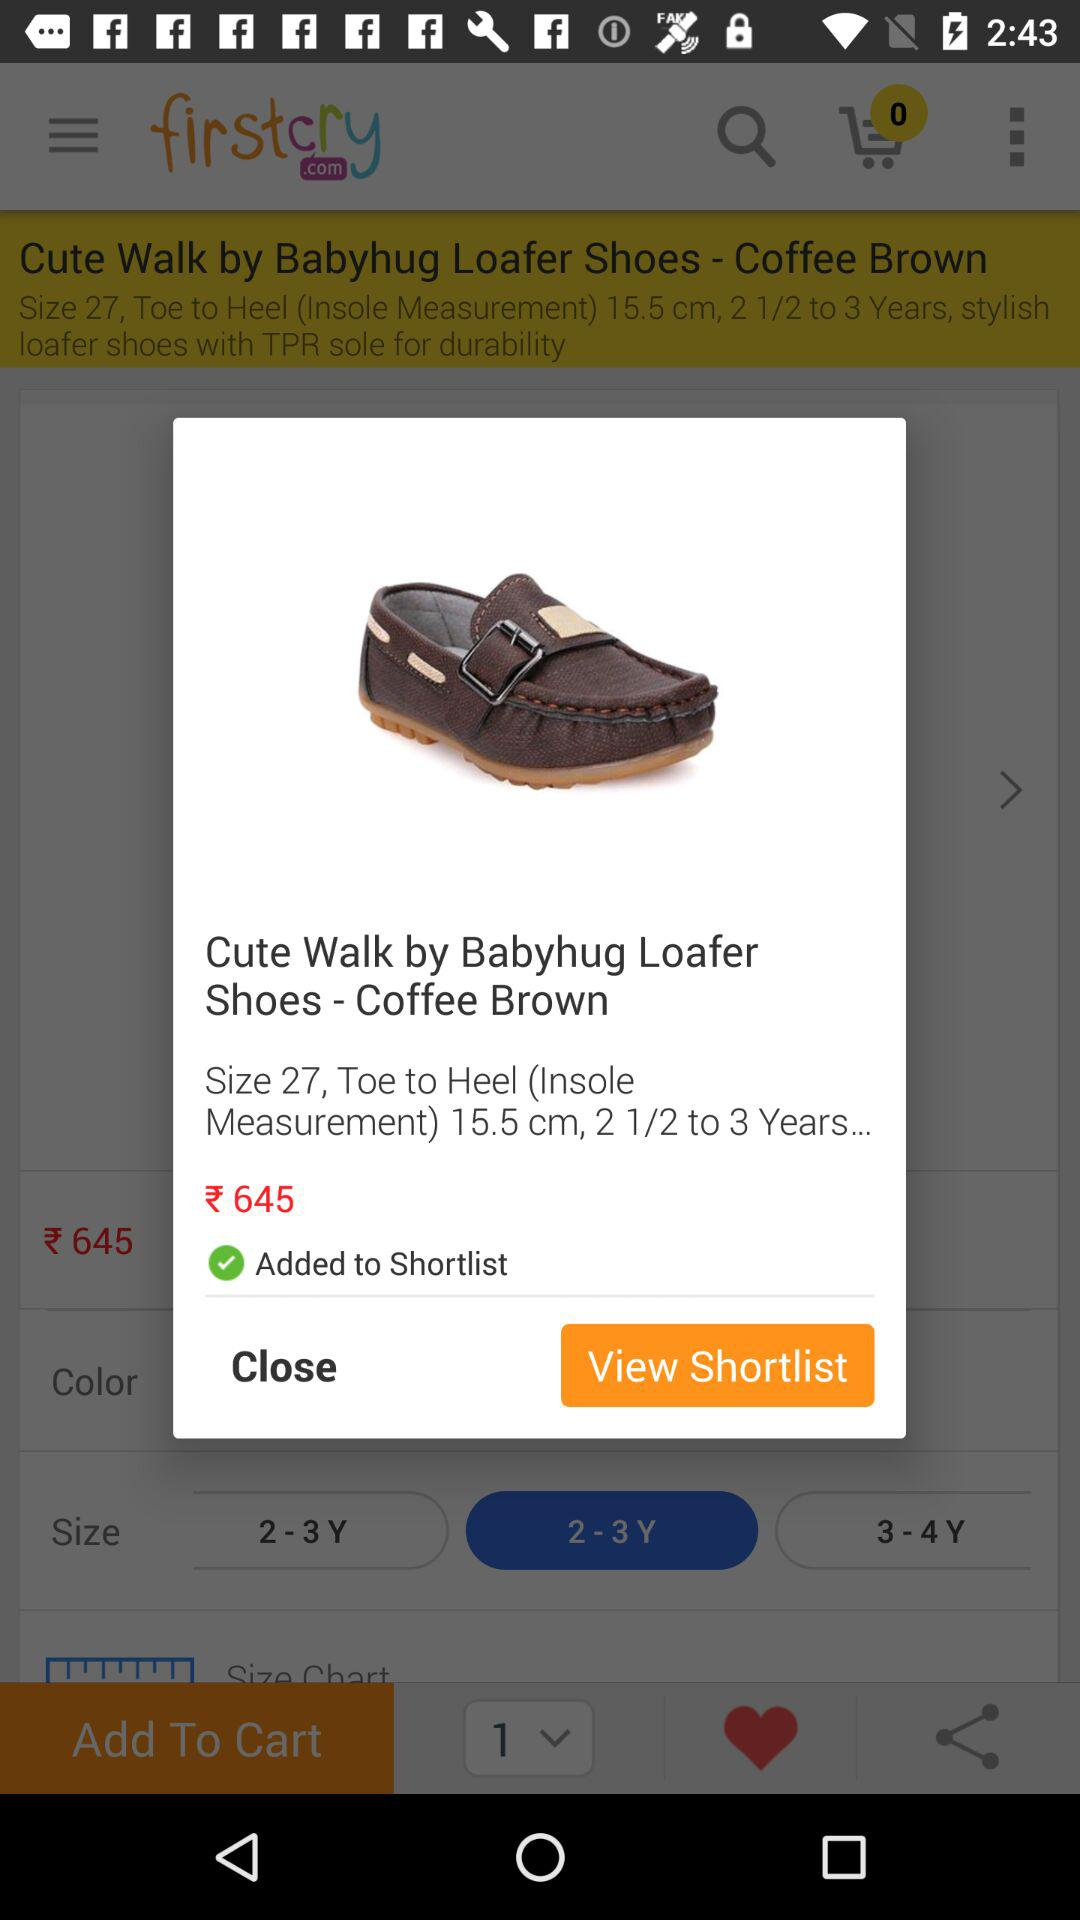How many centimeters is the shoe's toe to heel measurement?
Answer the question using a single word or phrase. 15.5 